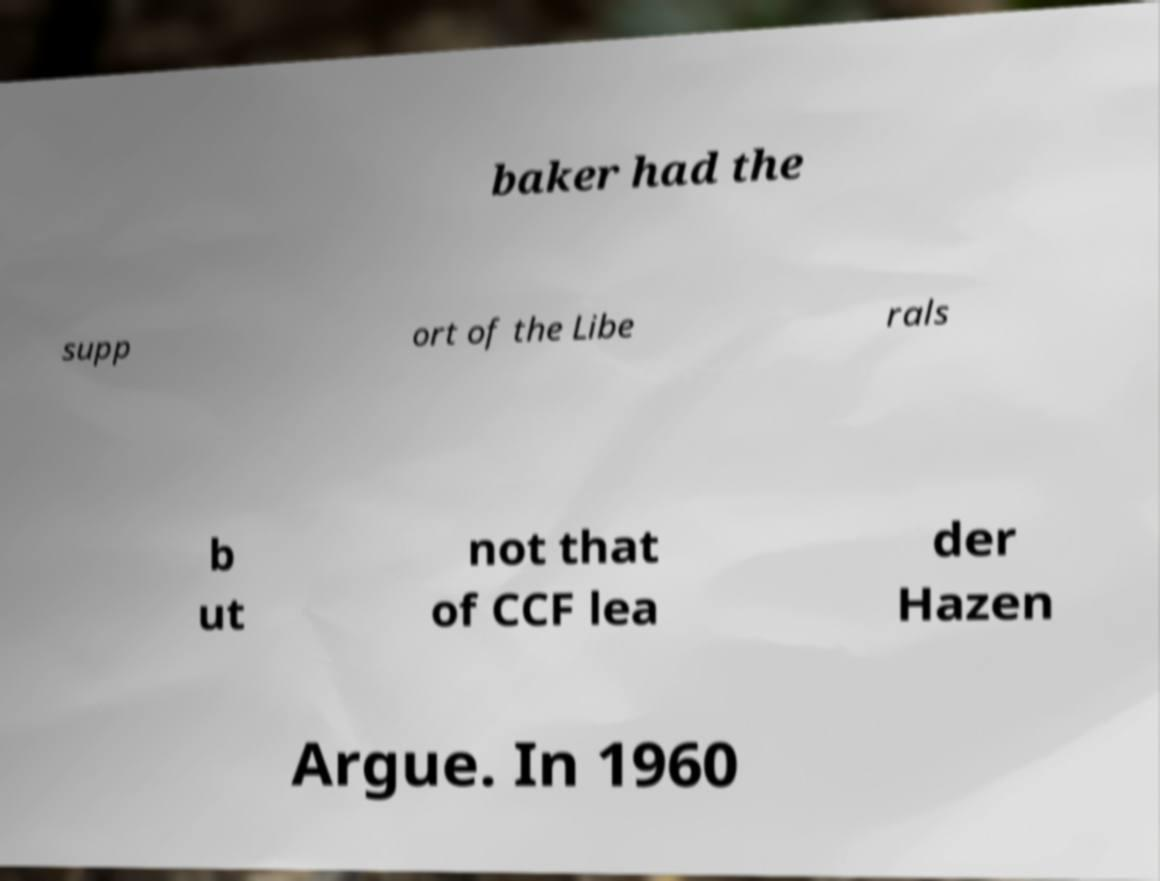Please read and relay the text visible in this image. What does it say? baker had the supp ort of the Libe rals b ut not that of CCF lea der Hazen Argue. In 1960 